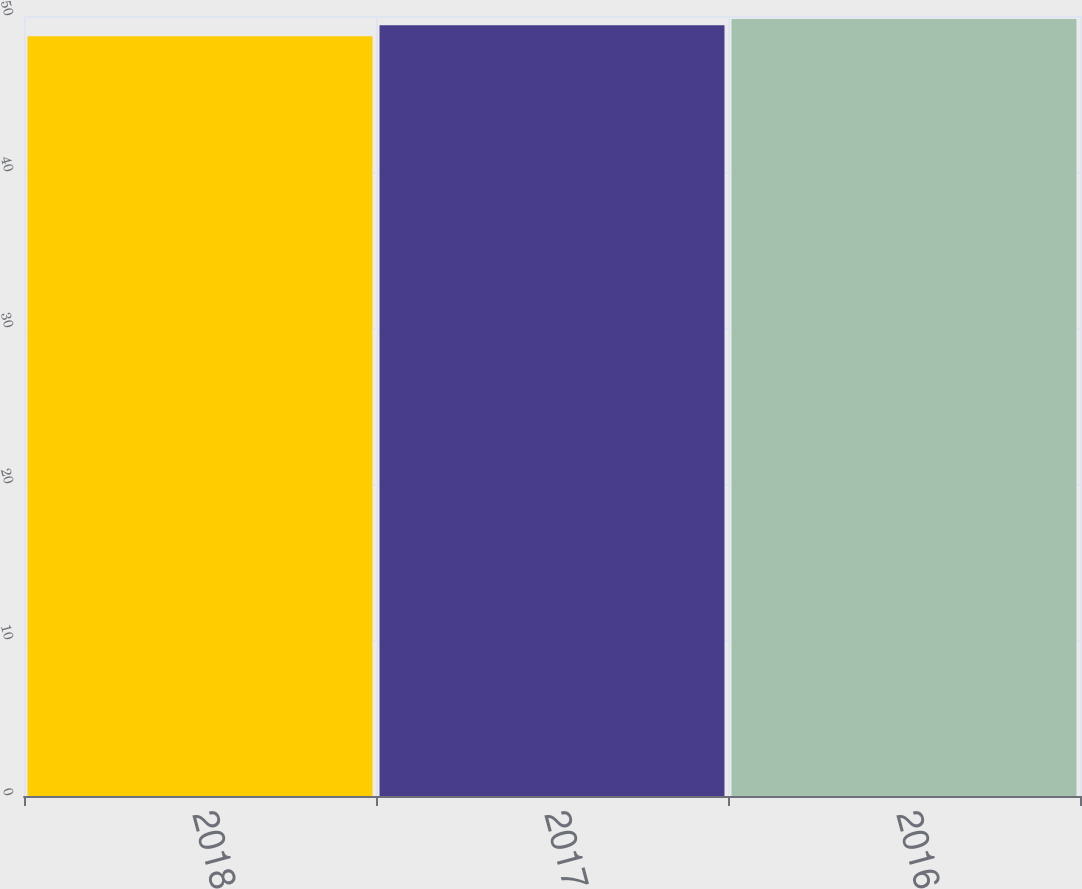<chart> <loc_0><loc_0><loc_500><loc_500><bar_chart><fcel>2018<fcel>2017<fcel>2016<nl><fcel>48.7<fcel>49.4<fcel>49.8<nl></chart> 